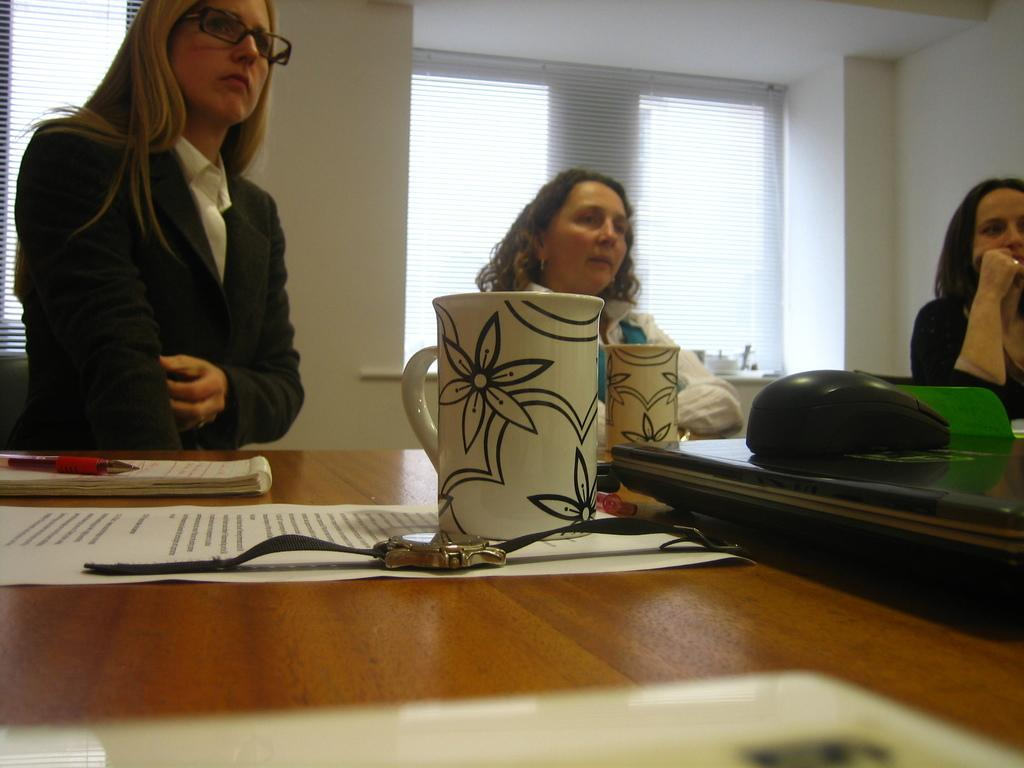How many persons are in the image? There are three persons in the image. What are the persons doing in the image? The persons are sitting on chairs. Can you describe the arrangement of the chairs and table? The chairs are arranged around a table. What objects can be seen on the table? There is a mug, a watch, a paper, a book, a pen, and a tab on the table. What is visible in the background of the image? There is a wall and a window in the background of the image. How many pigs are visible on the sidewalk in the image? There are no pigs or sidewalks present in the image. What is the number written on the paper on the table? The provided facts do not mention any numbers written on the paper, so we cannot determine that information from the image. 